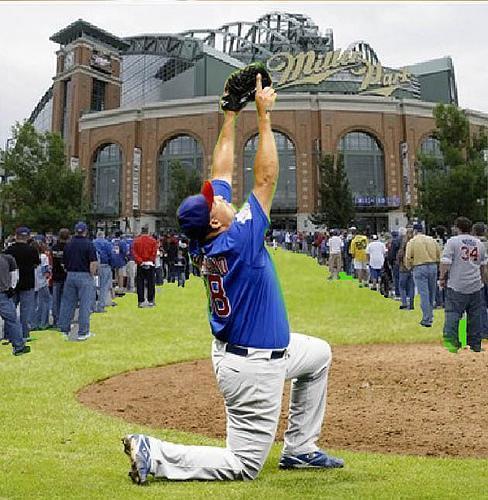How many people are in the picture?
Give a very brief answer. 6. 